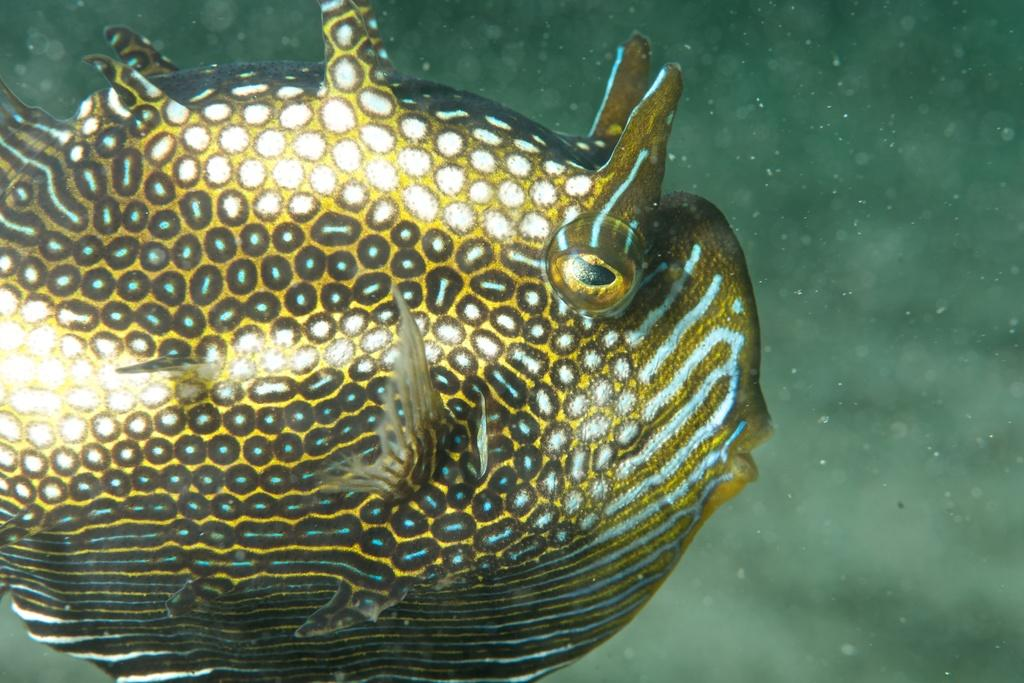What type of environment is shown in the image? The image depicts an underwater environment. Can you describe any specific features or objects in the image? There is a fish on the left side of the image. What type of shirt is the fish wearing in the image? There is no shirt present on the fish in the image, as it is a fish in an underwater environment. 